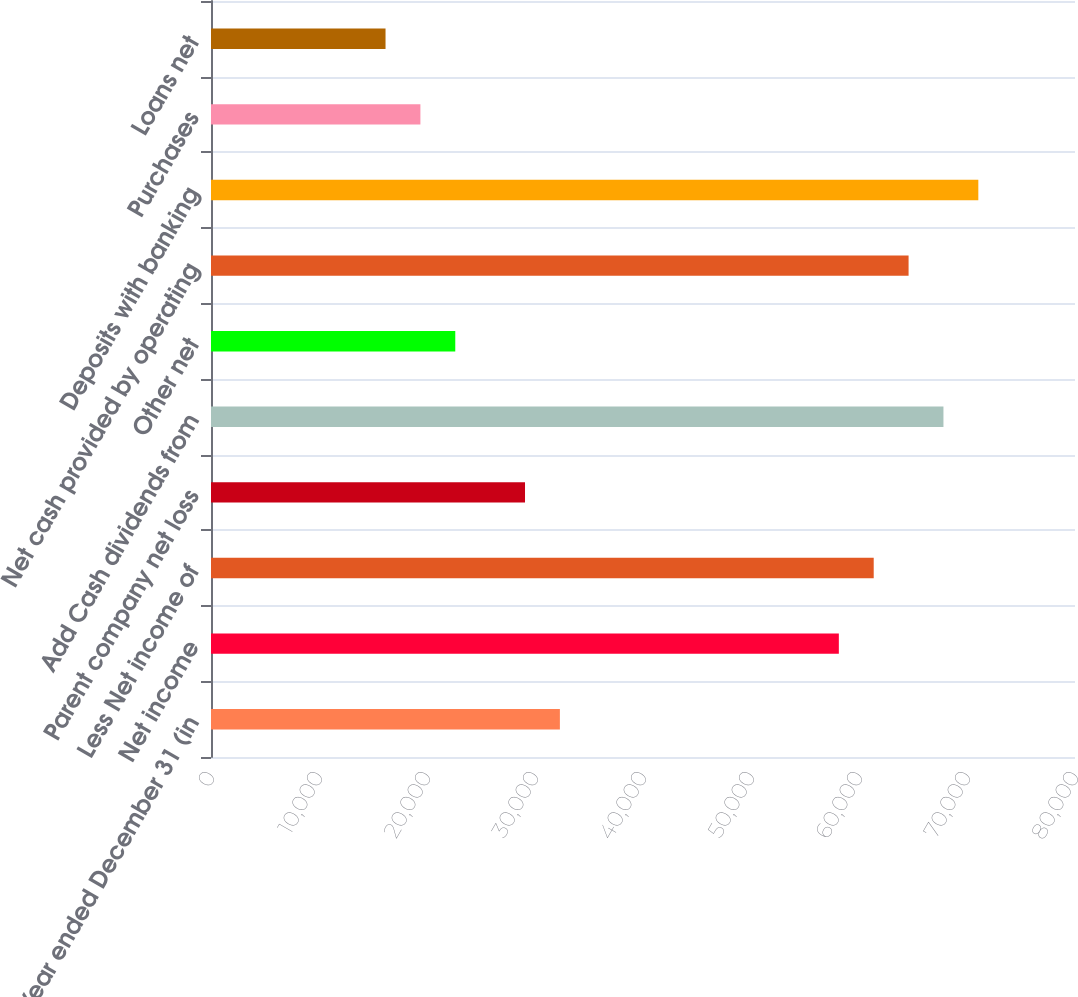<chart> <loc_0><loc_0><loc_500><loc_500><bar_chart><fcel>Year ended December 31 (in<fcel>Net income<fcel>Less Net income of<fcel>Parent company net loss<fcel>Add Cash dividends from<fcel>Other net<fcel>Net cash provided by operating<fcel>Deposits with banking<fcel>Purchases<fcel>Loans net<nl><fcel>32304<fcel>58133.6<fcel>61362.3<fcel>29075.3<fcel>67819.7<fcel>22617.9<fcel>64591<fcel>71048.4<fcel>19389.2<fcel>16160.5<nl></chart> 